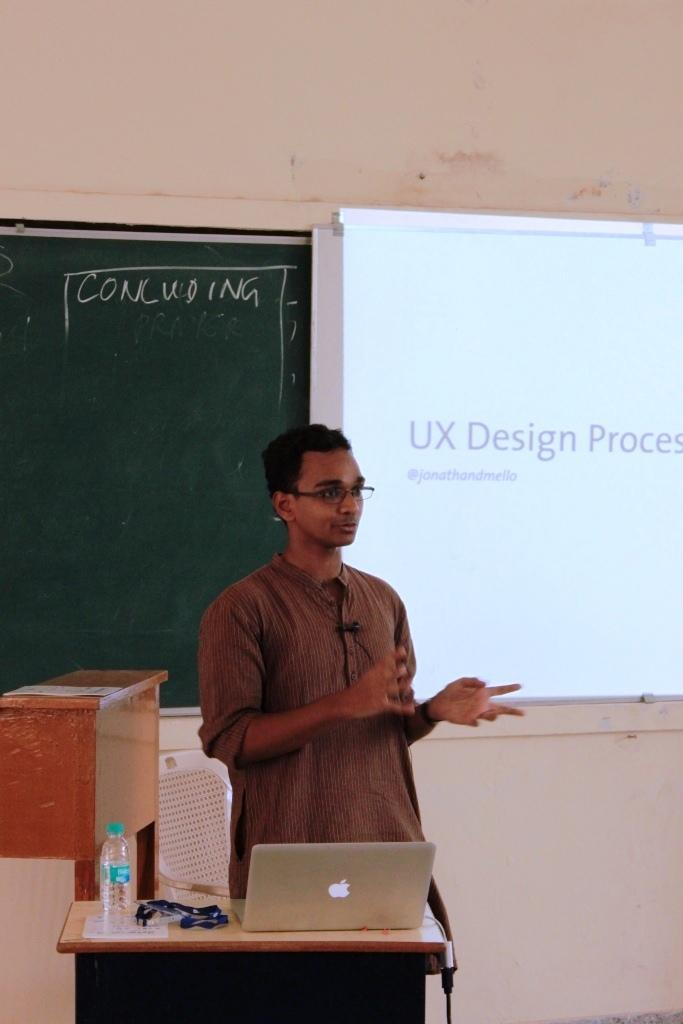Who is present in the image? There is a man in the image. What is the man doing in the image? The man is near a table. What objects are on the table? There is a laptop and a water bottle on the table. What can be seen in the background of the image? There is a wall, a board, a screen, and a chair in the background of the image. What type of pear is being exchanged between the man and the person behind the door in the image? There is no door or person present in the image, and no pear is being exchanged. 